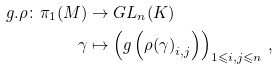<formula> <loc_0><loc_0><loc_500><loc_500>g . \rho \colon \pi _ { 1 } ( M ) & \rightarrow G L _ { n } ( K ) \\ \gamma & \mapsto \left ( g \left ( { \rho ( \gamma ) } _ { i , j } \right ) \right ) _ { 1 \leqslant i , j \leqslant n } \, ,</formula> 